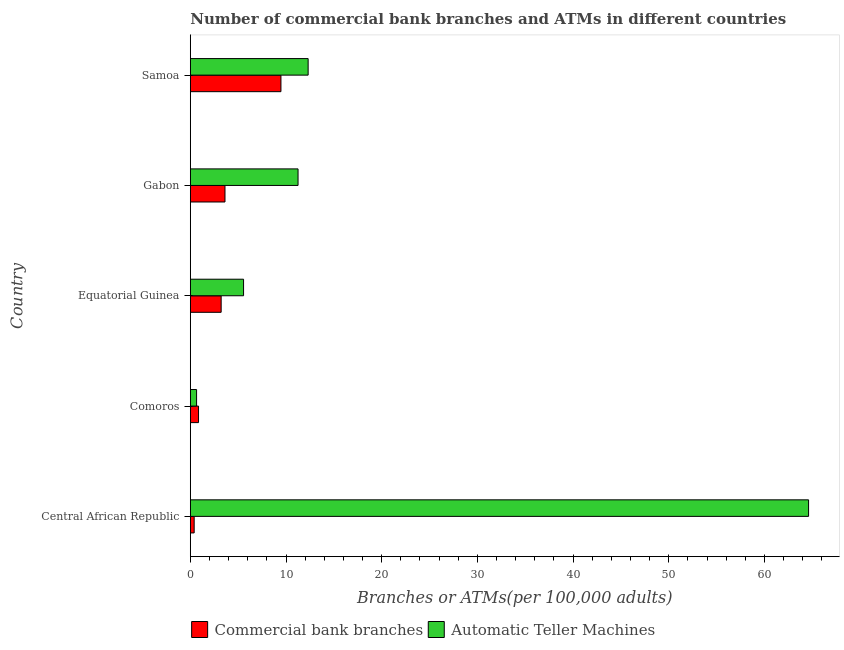How many different coloured bars are there?
Provide a short and direct response. 2. Are the number of bars on each tick of the Y-axis equal?
Provide a short and direct response. Yes. How many bars are there on the 2nd tick from the bottom?
Give a very brief answer. 2. What is the label of the 2nd group of bars from the top?
Your response must be concise. Gabon. What is the number of commercal bank branches in Samoa?
Ensure brevity in your answer.  9.47. Across all countries, what is the maximum number of atms?
Offer a very short reply. 64.61. Across all countries, what is the minimum number of atms?
Your response must be concise. 0.66. In which country was the number of atms maximum?
Offer a very short reply. Central African Republic. In which country was the number of atms minimum?
Offer a very short reply. Comoros. What is the total number of atms in the graph?
Make the answer very short. 94.4. What is the difference between the number of atms in Central African Republic and that in Samoa?
Offer a terse response. 52.29. What is the difference between the number of atms in Equatorial Guinea and the number of commercal bank branches in Central African Republic?
Offer a very short reply. 5.16. What is the average number of atms per country?
Make the answer very short. 18.88. What is the difference between the number of atms and number of commercal bank branches in Equatorial Guinea?
Your response must be concise. 2.34. What is the ratio of the number of atms in Comoros to that in Equatorial Guinea?
Give a very brief answer. 0.12. Is the difference between the number of atms in Equatorial Guinea and Gabon greater than the difference between the number of commercal bank branches in Equatorial Guinea and Gabon?
Your response must be concise. No. What is the difference between the highest and the second highest number of atms?
Give a very brief answer. 52.29. What is the difference between the highest and the lowest number of commercal bank branches?
Your answer should be very brief. 9.07. What does the 2nd bar from the top in Gabon represents?
Provide a short and direct response. Commercial bank branches. What does the 1st bar from the bottom in Equatorial Guinea represents?
Provide a succinct answer. Commercial bank branches. How many bars are there?
Offer a very short reply. 10. How many countries are there in the graph?
Provide a short and direct response. 5. How many legend labels are there?
Provide a succinct answer. 2. What is the title of the graph?
Make the answer very short. Number of commercial bank branches and ATMs in different countries. What is the label or title of the X-axis?
Offer a very short reply. Branches or ATMs(per 100,0 adults). What is the Branches or ATMs(per 100,000 adults) in Commercial bank branches in Central African Republic?
Provide a short and direct response. 0.4. What is the Branches or ATMs(per 100,000 adults) in Automatic Teller Machines in Central African Republic?
Keep it short and to the point. 64.61. What is the Branches or ATMs(per 100,000 adults) of Commercial bank branches in Comoros?
Ensure brevity in your answer.  0.86. What is the Branches or ATMs(per 100,000 adults) of Automatic Teller Machines in Comoros?
Offer a terse response. 0.66. What is the Branches or ATMs(per 100,000 adults) in Commercial bank branches in Equatorial Guinea?
Offer a terse response. 3.22. What is the Branches or ATMs(per 100,000 adults) of Automatic Teller Machines in Equatorial Guinea?
Keep it short and to the point. 5.57. What is the Branches or ATMs(per 100,000 adults) of Commercial bank branches in Gabon?
Your answer should be very brief. 3.62. What is the Branches or ATMs(per 100,000 adults) in Automatic Teller Machines in Gabon?
Provide a short and direct response. 11.26. What is the Branches or ATMs(per 100,000 adults) in Commercial bank branches in Samoa?
Your answer should be very brief. 9.47. What is the Branches or ATMs(per 100,000 adults) in Automatic Teller Machines in Samoa?
Your answer should be compact. 12.31. Across all countries, what is the maximum Branches or ATMs(per 100,000 adults) of Commercial bank branches?
Your answer should be very brief. 9.47. Across all countries, what is the maximum Branches or ATMs(per 100,000 adults) in Automatic Teller Machines?
Provide a short and direct response. 64.61. Across all countries, what is the minimum Branches or ATMs(per 100,000 adults) in Commercial bank branches?
Your answer should be very brief. 0.4. Across all countries, what is the minimum Branches or ATMs(per 100,000 adults) in Automatic Teller Machines?
Provide a short and direct response. 0.66. What is the total Branches or ATMs(per 100,000 adults) of Commercial bank branches in the graph?
Provide a short and direct response. 17.59. What is the total Branches or ATMs(per 100,000 adults) in Automatic Teller Machines in the graph?
Provide a succinct answer. 94.4. What is the difference between the Branches or ATMs(per 100,000 adults) of Commercial bank branches in Central African Republic and that in Comoros?
Keep it short and to the point. -0.46. What is the difference between the Branches or ATMs(per 100,000 adults) in Automatic Teller Machines in Central African Republic and that in Comoros?
Offer a terse response. 63.95. What is the difference between the Branches or ATMs(per 100,000 adults) of Commercial bank branches in Central African Republic and that in Equatorial Guinea?
Make the answer very short. -2.82. What is the difference between the Branches or ATMs(per 100,000 adults) of Automatic Teller Machines in Central African Republic and that in Equatorial Guinea?
Provide a succinct answer. 59.04. What is the difference between the Branches or ATMs(per 100,000 adults) in Commercial bank branches in Central African Republic and that in Gabon?
Your response must be concise. -3.22. What is the difference between the Branches or ATMs(per 100,000 adults) in Automatic Teller Machines in Central African Republic and that in Gabon?
Provide a succinct answer. 53.35. What is the difference between the Branches or ATMs(per 100,000 adults) in Commercial bank branches in Central African Republic and that in Samoa?
Provide a short and direct response. -9.07. What is the difference between the Branches or ATMs(per 100,000 adults) in Automatic Teller Machines in Central African Republic and that in Samoa?
Your answer should be compact. 52.29. What is the difference between the Branches or ATMs(per 100,000 adults) of Commercial bank branches in Comoros and that in Equatorial Guinea?
Give a very brief answer. -2.36. What is the difference between the Branches or ATMs(per 100,000 adults) of Automatic Teller Machines in Comoros and that in Equatorial Guinea?
Give a very brief answer. -4.91. What is the difference between the Branches or ATMs(per 100,000 adults) in Commercial bank branches in Comoros and that in Gabon?
Offer a very short reply. -2.76. What is the difference between the Branches or ATMs(per 100,000 adults) in Automatic Teller Machines in Comoros and that in Gabon?
Give a very brief answer. -10.6. What is the difference between the Branches or ATMs(per 100,000 adults) of Commercial bank branches in Comoros and that in Samoa?
Give a very brief answer. -8.61. What is the difference between the Branches or ATMs(per 100,000 adults) in Automatic Teller Machines in Comoros and that in Samoa?
Make the answer very short. -11.66. What is the difference between the Branches or ATMs(per 100,000 adults) of Commercial bank branches in Equatorial Guinea and that in Gabon?
Provide a short and direct response. -0.4. What is the difference between the Branches or ATMs(per 100,000 adults) in Automatic Teller Machines in Equatorial Guinea and that in Gabon?
Offer a very short reply. -5.69. What is the difference between the Branches or ATMs(per 100,000 adults) of Commercial bank branches in Equatorial Guinea and that in Samoa?
Give a very brief answer. -6.25. What is the difference between the Branches or ATMs(per 100,000 adults) in Automatic Teller Machines in Equatorial Guinea and that in Samoa?
Provide a short and direct response. -6.75. What is the difference between the Branches or ATMs(per 100,000 adults) of Commercial bank branches in Gabon and that in Samoa?
Provide a succinct answer. -5.85. What is the difference between the Branches or ATMs(per 100,000 adults) of Automatic Teller Machines in Gabon and that in Samoa?
Keep it short and to the point. -1.05. What is the difference between the Branches or ATMs(per 100,000 adults) of Commercial bank branches in Central African Republic and the Branches or ATMs(per 100,000 adults) of Automatic Teller Machines in Comoros?
Your answer should be very brief. -0.25. What is the difference between the Branches or ATMs(per 100,000 adults) of Commercial bank branches in Central African Republic and the Branches or ATMs(per 100,000 adults) of Automatic Teller Machines in Equatorial Guinea?
Provide a short and direct response. -5.16. What is the difference between the Branches or ATMs(per 100,000 adults) of Commercial bank branches in Central African Republic and the Branches or ATMs(per 100,000 adults) of Automatic Teller Machines in Gabon?
Ensure brevity in your answer.  -10.86. What is the difference between the Branches or ATMs(per 100,000 adults) in Commercial bank branches in Central African Republic and the Branches or ATMs(per 100,000 adults) in Automatic Teller Machines in Samoa?
Your answer should be very brief. -11.91. What is the difference between the Branches or ATMs(per 100,000 adults) in Commercial bank branches in Comoros and the Branches or ATMs(per 100,000 adults) in Automatic Teller Machines in Equatorial Guinea?
Offer a very short reply. -4.71. What is the difference between the Branches or ATMs(per 100,000 adults) of Commercial bank branches in Comoros and the Branches or ATMs(per 100,000 adults) of Automatic Teller Machines in Gabon?
Ensure brevity in your answer.  -10.4. What is the difference between the Branches or ATMs(per 100,000 adults) of Commercial bank branches in Comoros and the Branches or ATMs(per 100,000 adults) of Automatic Teller Machines in Samoa?
Make the answer very short. -11.45. What is the difference between the Branches or ATMs(per 100,000 adults) of Commercial bank branches in Equatorial Guinea and the Branches or ATMs(per 100,000 adults) of Automatic Teller Machines in Gabon?
Offer a terse response. -8.04. What is the difference between the Branches or ATMs(per 100,000 adults) of Commercial bank branches in Equatorial Guinea and the Branches or ATMs(per 100,000 adults) of Automatic Teller Machines in Samoa?
Provide a succinct answer. -9.09. What is the difference between the Branches or ATMs(per 100,000 adults) of Commercial bank branches in Gabon and the Branches or ATMs(per 100,000 adults) of Automatic Teller Machines in Samoa?
Provide a succinct answer. -8.69. What is the average Branches or ATMs(per 100,000 adults) in Commercial bank branches per country?
Your answer should be very brief. 3.52. What is the average Branches or ATMs(per 100,000 adults) of Automatic Teller Machines per country?
Your response must be concise. 18.88. What is the difference between the Branches or ATMs(per 100,000 adults) in Commercial bank branches and Branches or ATMs(per 100,000 adults) in Automatic Teller Machines in Central African Republic?
Make the answer very short. -64.2. What is the difference between the Branches or ATMs(per 100,000 adults) of Commercial bank branches and Branches or ATMs(per 100,000 adults) of Automatic Teller Machines in Comoros?
Offer a terse response. 0.2. What is the difference between the Branches or ATMs(per 100,000 adults) of Commercial bank branches and Branches or ATMs(per 100,000 adults) of Automatic Teller Machines in Equatorial Guinea?
Provide a succinct answer. -2.34. What is the difference between the Branches or ATMs(per 100,000 adults) in Commercial bank branches and Branches or ATMs(per 100,000 adults) in Automatic Teller Machines in Gabon?
Make the answer very short. -7.63. What is the difference between the Branches or ATMs(per 100,000 adults) of Commercial bank branches and Branches or ATMs(per 100,000 adults) of Automatic Teller Machines in Samoa?
Your answer should be compact. -2.84. What is the ratio of the Branches or ATMs(per 100,000 adults) of Commercial bank branches in Central African Republic to that in Comoros?
Provide a short and direct response. 0.47. What is the ratio of the Branches or ATMs(per 100,000 adults) in Automatic Teller Machines in Central African Republic to that in Comoros?
Your response must be concise. 98.45. What is the ratio of the Branches or ATMs(per 100,000 adults) of Commercial bank branches in Central African Republic to that in Equatorial Guinea?
Ensure brevity in your answer.  0.13. What is the ratio of the Branches or ATMs(per 100,000 adults) in Automatic Teller Machines in Central African Republic to that in Equatorial Guinea?
Offer a terse response. 11.61. What is the ratio of the Branches or ATMs(per 100,000 adults) in Commercial bank branches in Central African Republic to that in Gabon?
Keep it short and to the point. 0.11. What is the ratio of the Branches or ATMs(per 100,000 adults) of Automatic Teller Machines in Central African Republic to that in Gabon?
Offer a very short reply. 5.74. What is the ratio of the Branches or ATMs(per 100,000 adults) of Commercial bank branches in Central African Republic to that in Samoa?
Offer a terse response. 0.04. What is the ratio of the Branches or ATMs(per 100,000 adults) of Automatic Teller Machines in Central African Republic to that in Samoa?
Offer a very short reply. 5.25. What is the ratio of the Branches or ATMs(per 100,000 adults) of Commercial bank branches in Comoros to that in Equatorial Guinea?
Keep it short and to the point. 0.27. What is the ratio of the Branches or ATMs(per 100,000 adults) in Automatic Teller Machines in Comoros to that in Equatorial Guinea?
Give a very brief answer. 0.12. What is the ratio of the Branches or ATMs(per 100,000 adults) of Commercial bank branches in Comoros to that in Gabon?
Ensure brevity in your answer.  0.24. What is the ratio of the Branches or ATMs(per 100,000 adults) of Automatic Teller Machines in Comoros to that in Gabon?
Your answer should be very brief. 0.06. What is the ratio of the Branches or ATMs(per 100,000 adults) in Commercial bank branches in Comoros to that in Samoa?
Provide a short and direct response. 0.09. What is the ratio of the Branches or ATMs(per 100,000 adults) in Automatic Teller Machines in Comoros to that in Samoa?
Ensure brevity in your answer.  0.05. What is the ratio of the Branches or ATMs(per 100,000 adults) in Commercial bank branches in Equatorial Guinea to that in Gabon?
Ensure brevity in your answer.  0.89. What is the ratio of the Branches or ATMs(per 100,000 adults) in Automatic Teller Machines in Equatorial Guinea to that in Gabon?
Provide a short and direct response. 0.49. What is the ratio of the Branches or ATMs(per 100,000 adults) of Commercial bank branches in Equatorial Guinea to that in Samoa?
Offer a terse response. 0.34. What is the ratio of the Branches or ATMs(per 100,000 adults) of Automatic Teller Machines in Equatorial Guinea to that in Samoa?
Keep it short and to the point. 0.45. What is the ratio of the Branches or ATMs(per 100,000 adults) in Commercial bank branches in Gabon to that in Samoa?
Provide a short and direct response. 0.38. What is the ratio of the Branches or ATMs(per 100,000 adults) in Automatic Teller Machines in Gabon to that in Samoa?
Your answer should be very brief. 0.91. What is the difference between the highest and the second highest Branches or ATMs(per 100,000 adults) of Commercial bank branches?
Your response must be concise. 5.85. What is the difference between the highest and the second highest Branches or ATMs(per 100,000 adults) in Automatic Teller Machines?
Ensure brevity in your answer.  52.29. What is the difference between the highest and the lowest Branches or ATMs(per 100,000 adults) of Commercial bank branches?
Your answer should be compact. 9.07. What is the difference between the highest and the lowest Branches or ATMs(per 100,000 adults) in Automatic Teller Machines?
Your answer should be compact. 63.95. 